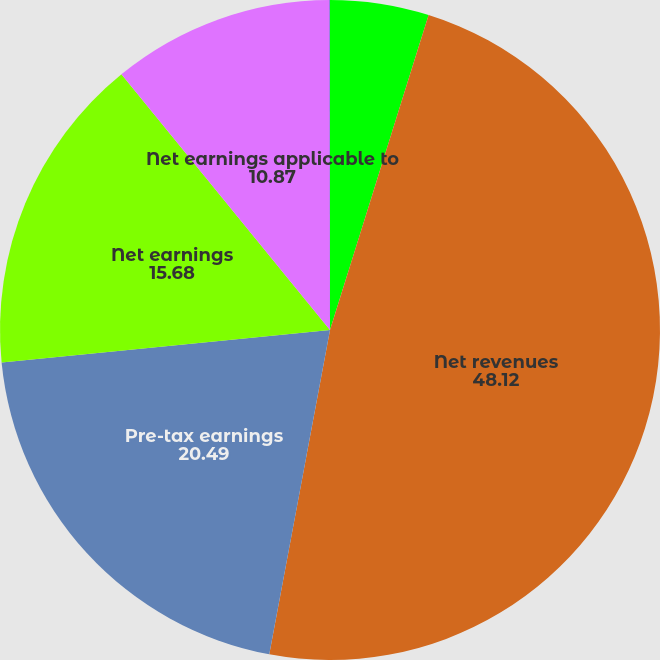Convert chart to OTSL. <chart><loc_0><loc_0><loc_500><loc_500><pie_chart><fcel>in millions except per share<fcel>Net revenues<fcel>Pre-tax earnings<fcel>Net earnings<fcel>Net earnings applicable to<fcel>Return on average common<nl><fcel>4.83%<fcel>48.12%<fcel>20.49%<fcel>15.68%<fcel>10.87%<fcel>0.02%<nl></chart> 